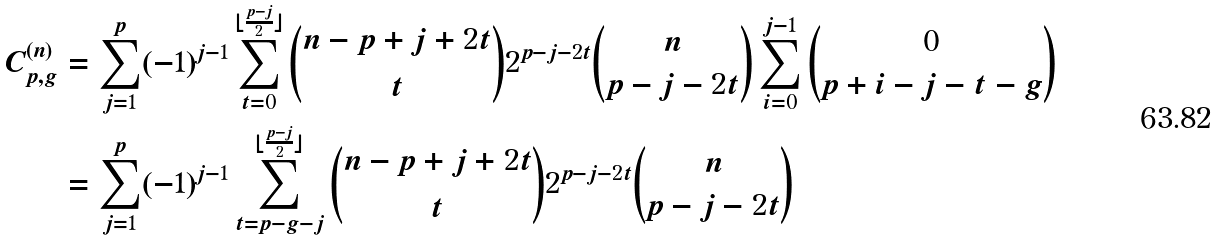<formula> <loc_0><loc_0><loc_500><loc_500>C _ { p , g } ^ { ( n ) } & = \sum _ { j = 1 } ^ { p } ( - 1 ) ^ { j - 1 } \sum _ { t = 0 } ^ { \lfloor \frac { p - j } { 2 } \rfloor } \binom { n - p + j + 2 t } { t } 2 ^ { p - j - 2 t } \binom { n } { p - j - 2 t } \sum _ { i = 0 } ^ { j - 1 } \binom { 0 } { p + i - j - t - g } \\ & = \sum _ { j = 1 } ^ { p } ( - 1 ) ^ { j - 1 } \sum _ { t = p - g - j } ^ { \lfloor \frac { p - j } { 2 } \rfloor } \binom { n - p + j + 2 t } { t } 2 ^ { p - j - 2 t } \binom { n } { p - j - 2 t }</formula> 